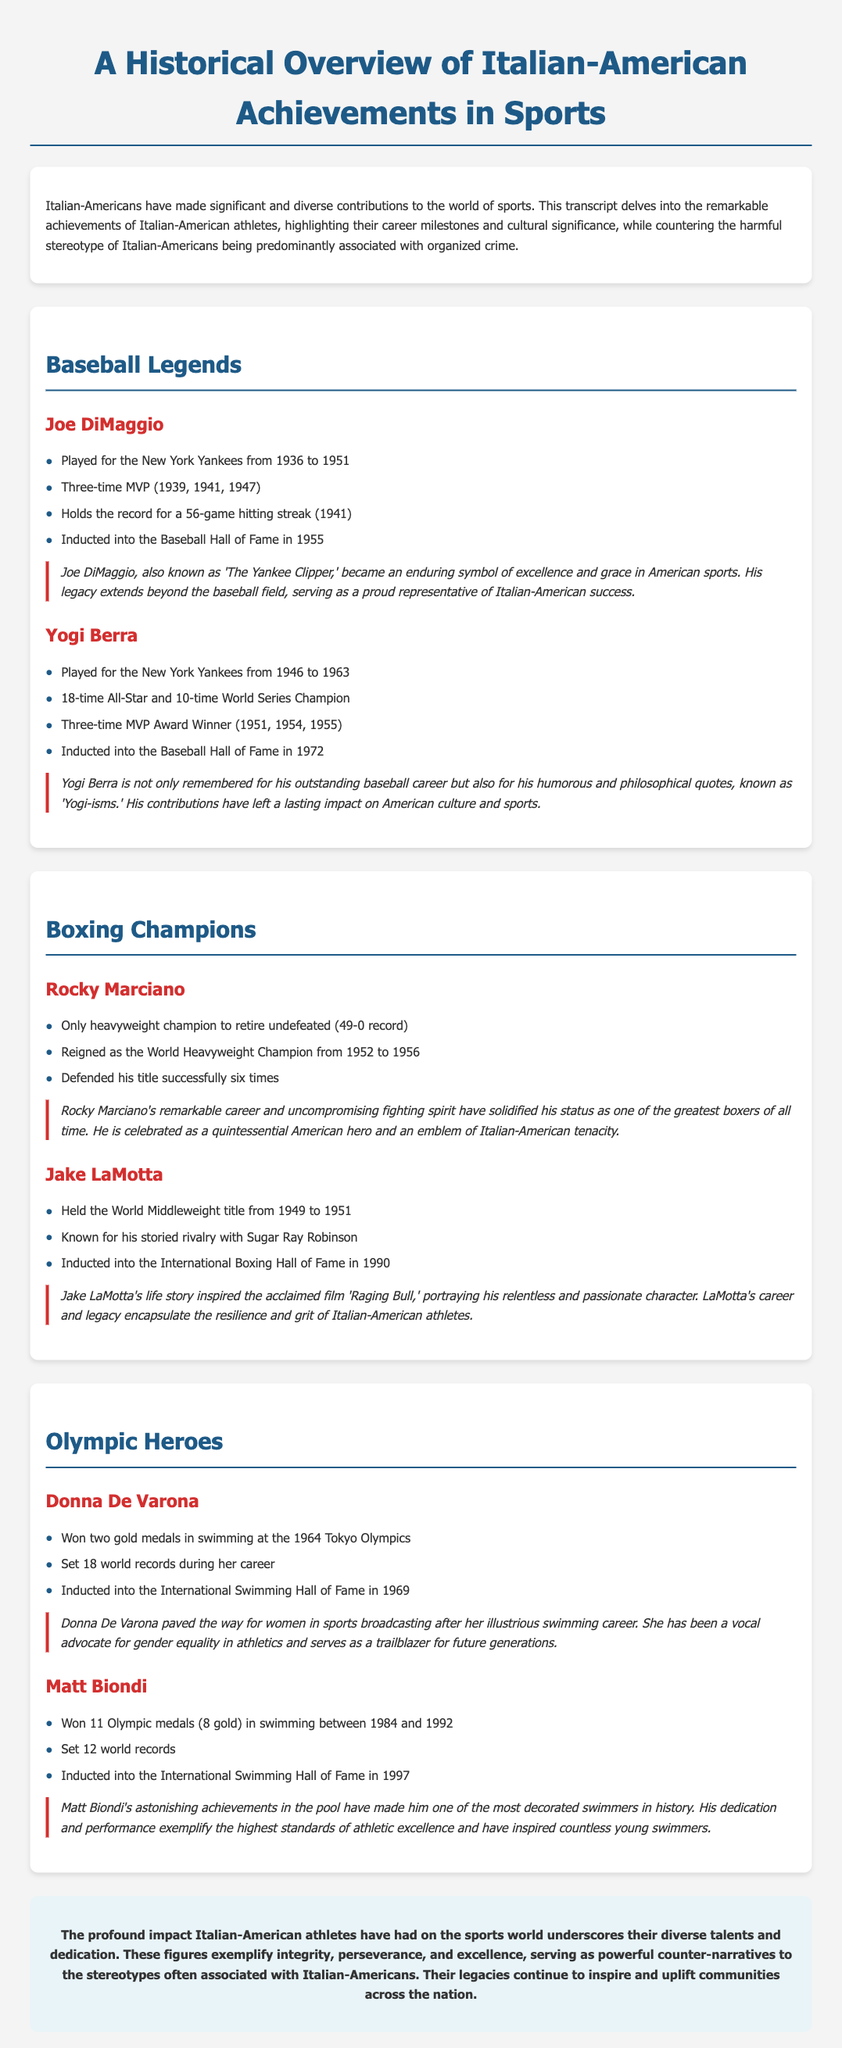what teams did Joe DiMaggio play for? Joe DiMaggio played for the New York Yankees during his career.
Answer: New York Yankees how many Olympic medals did Matt Biondi win? The document states that Matt Biondi won a total of 11 Olympic medals.
Answer: 11 who was known as 'The Yankee Clipper'? The document mentions that Joe DiMaggio is also known as 'The Yankee Clipper.'
Answer: Joe DiMaggio how many times did Yogi Berra win MVP? Yogi Berra is noted to have won the MVP award three times in the document.
Answer: three what year was Rocky Marciano the World Heavyweight Champion? Rocky Marciano reigned as the World Heavyweight Champion from 1952 to 1956 according to the document.
Answer: 1952 to 1956 which athlete has set 12 world records? The document specifies that Matt Biondi set 12 world records during his swimming career.
Answer: Matt Biondi what cultural significance is attributed to Donna De Varona? The document indicates that Donna De Varona paved the way for women in sports broadcasting.
Answer: paved the way for women in sports broadcasting how many times did Jake LaMotta hold the World Middleweight title? The document states that Jake LaMotta held the World Middleweight title from 1949 to 1951.
Answer: once who is referred to as a quintessential American hero? The document describes Rocky Marciano as a quintessential American hero.
Answer: Rocky Marciano 